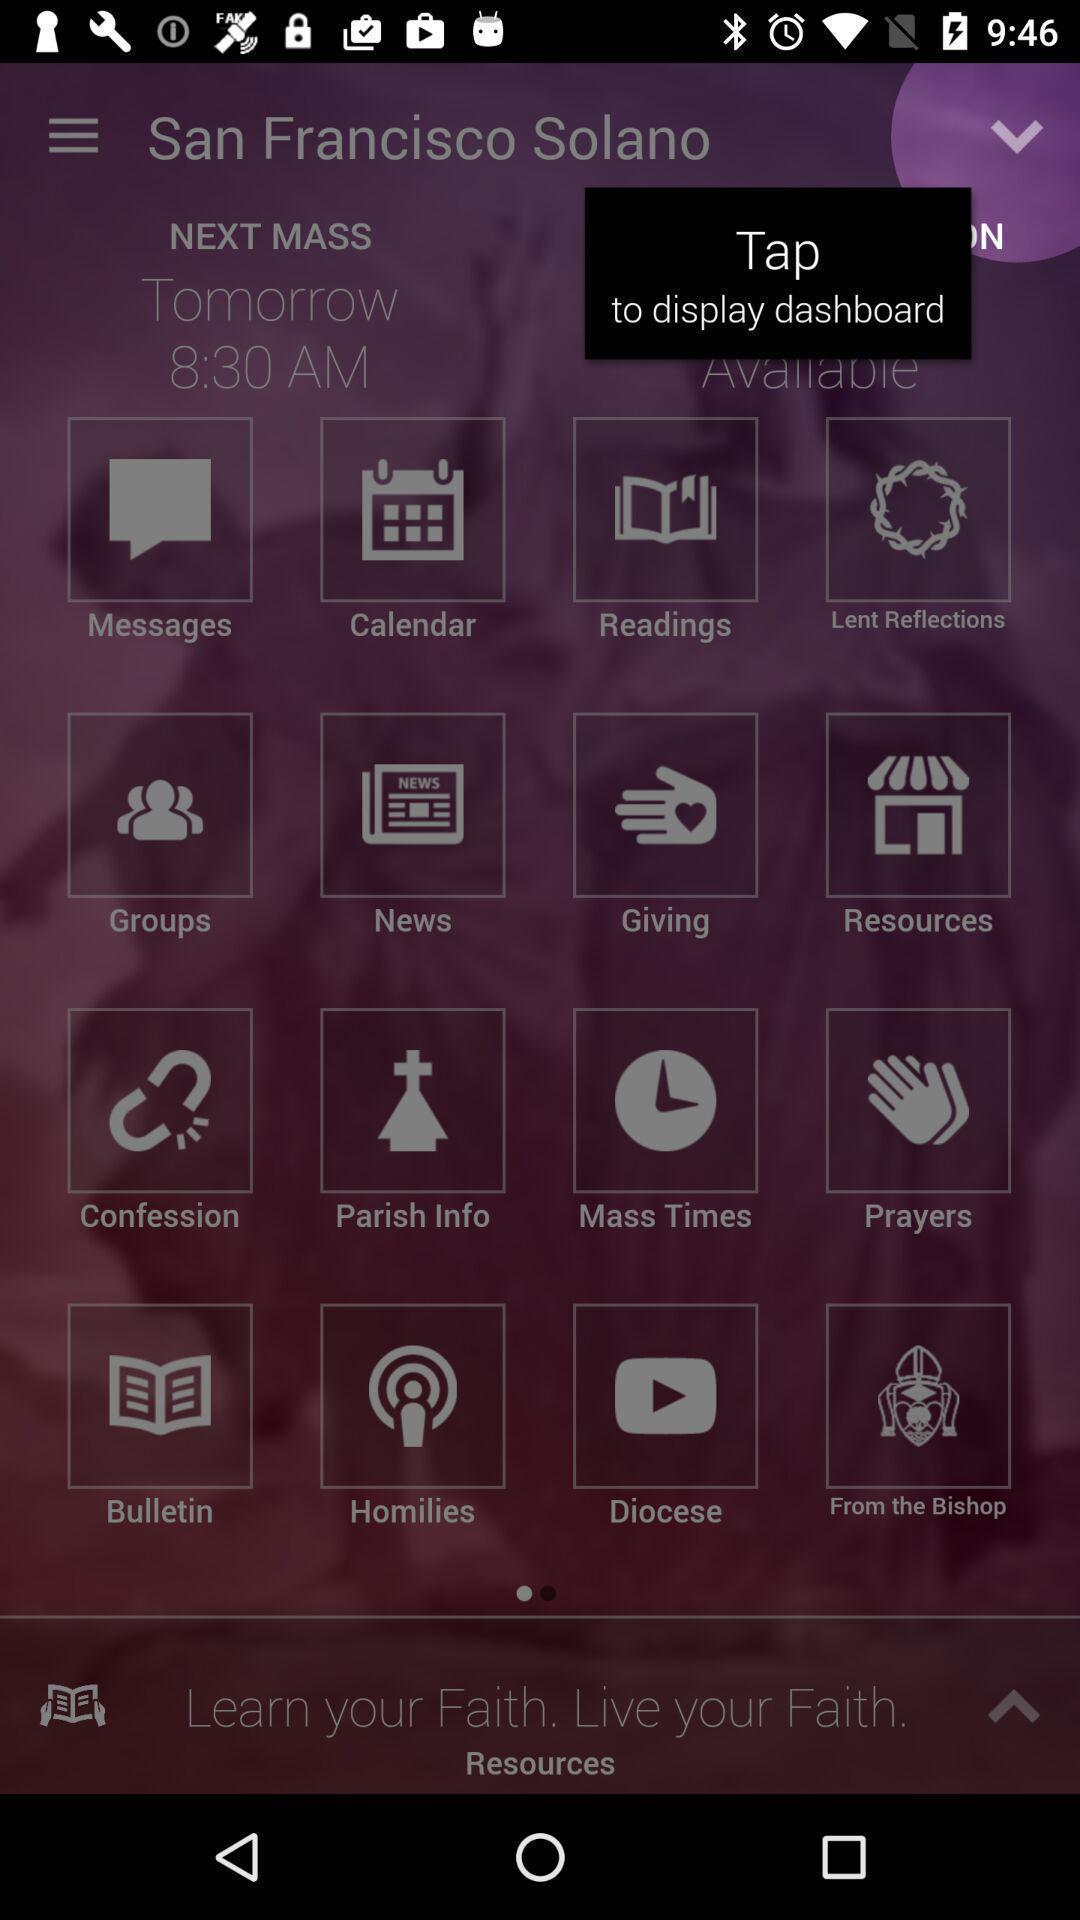Tell me what you see in this picture. Pop-up shows tap to display dashboard of learning app. 